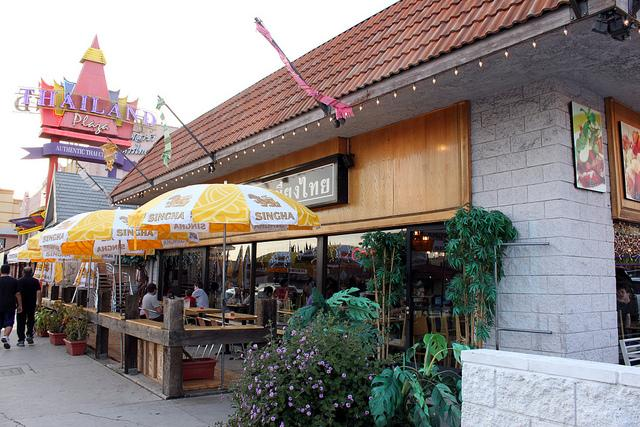What is the capital city of this country?

Choices:
A) taipei
B) bangkok
C) tokyo
D) manila bangkok 